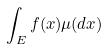<formula> <loc_0><loc_0><loc_500><loc_500>\int _ { E } f ( x ) \mu ( d x )</formula> 